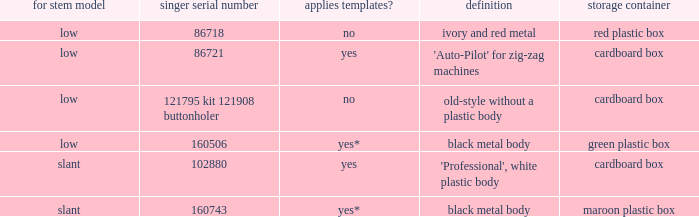What's the singer part number of the buttonholer whose storage case is a green plastic box? 160506.0. 